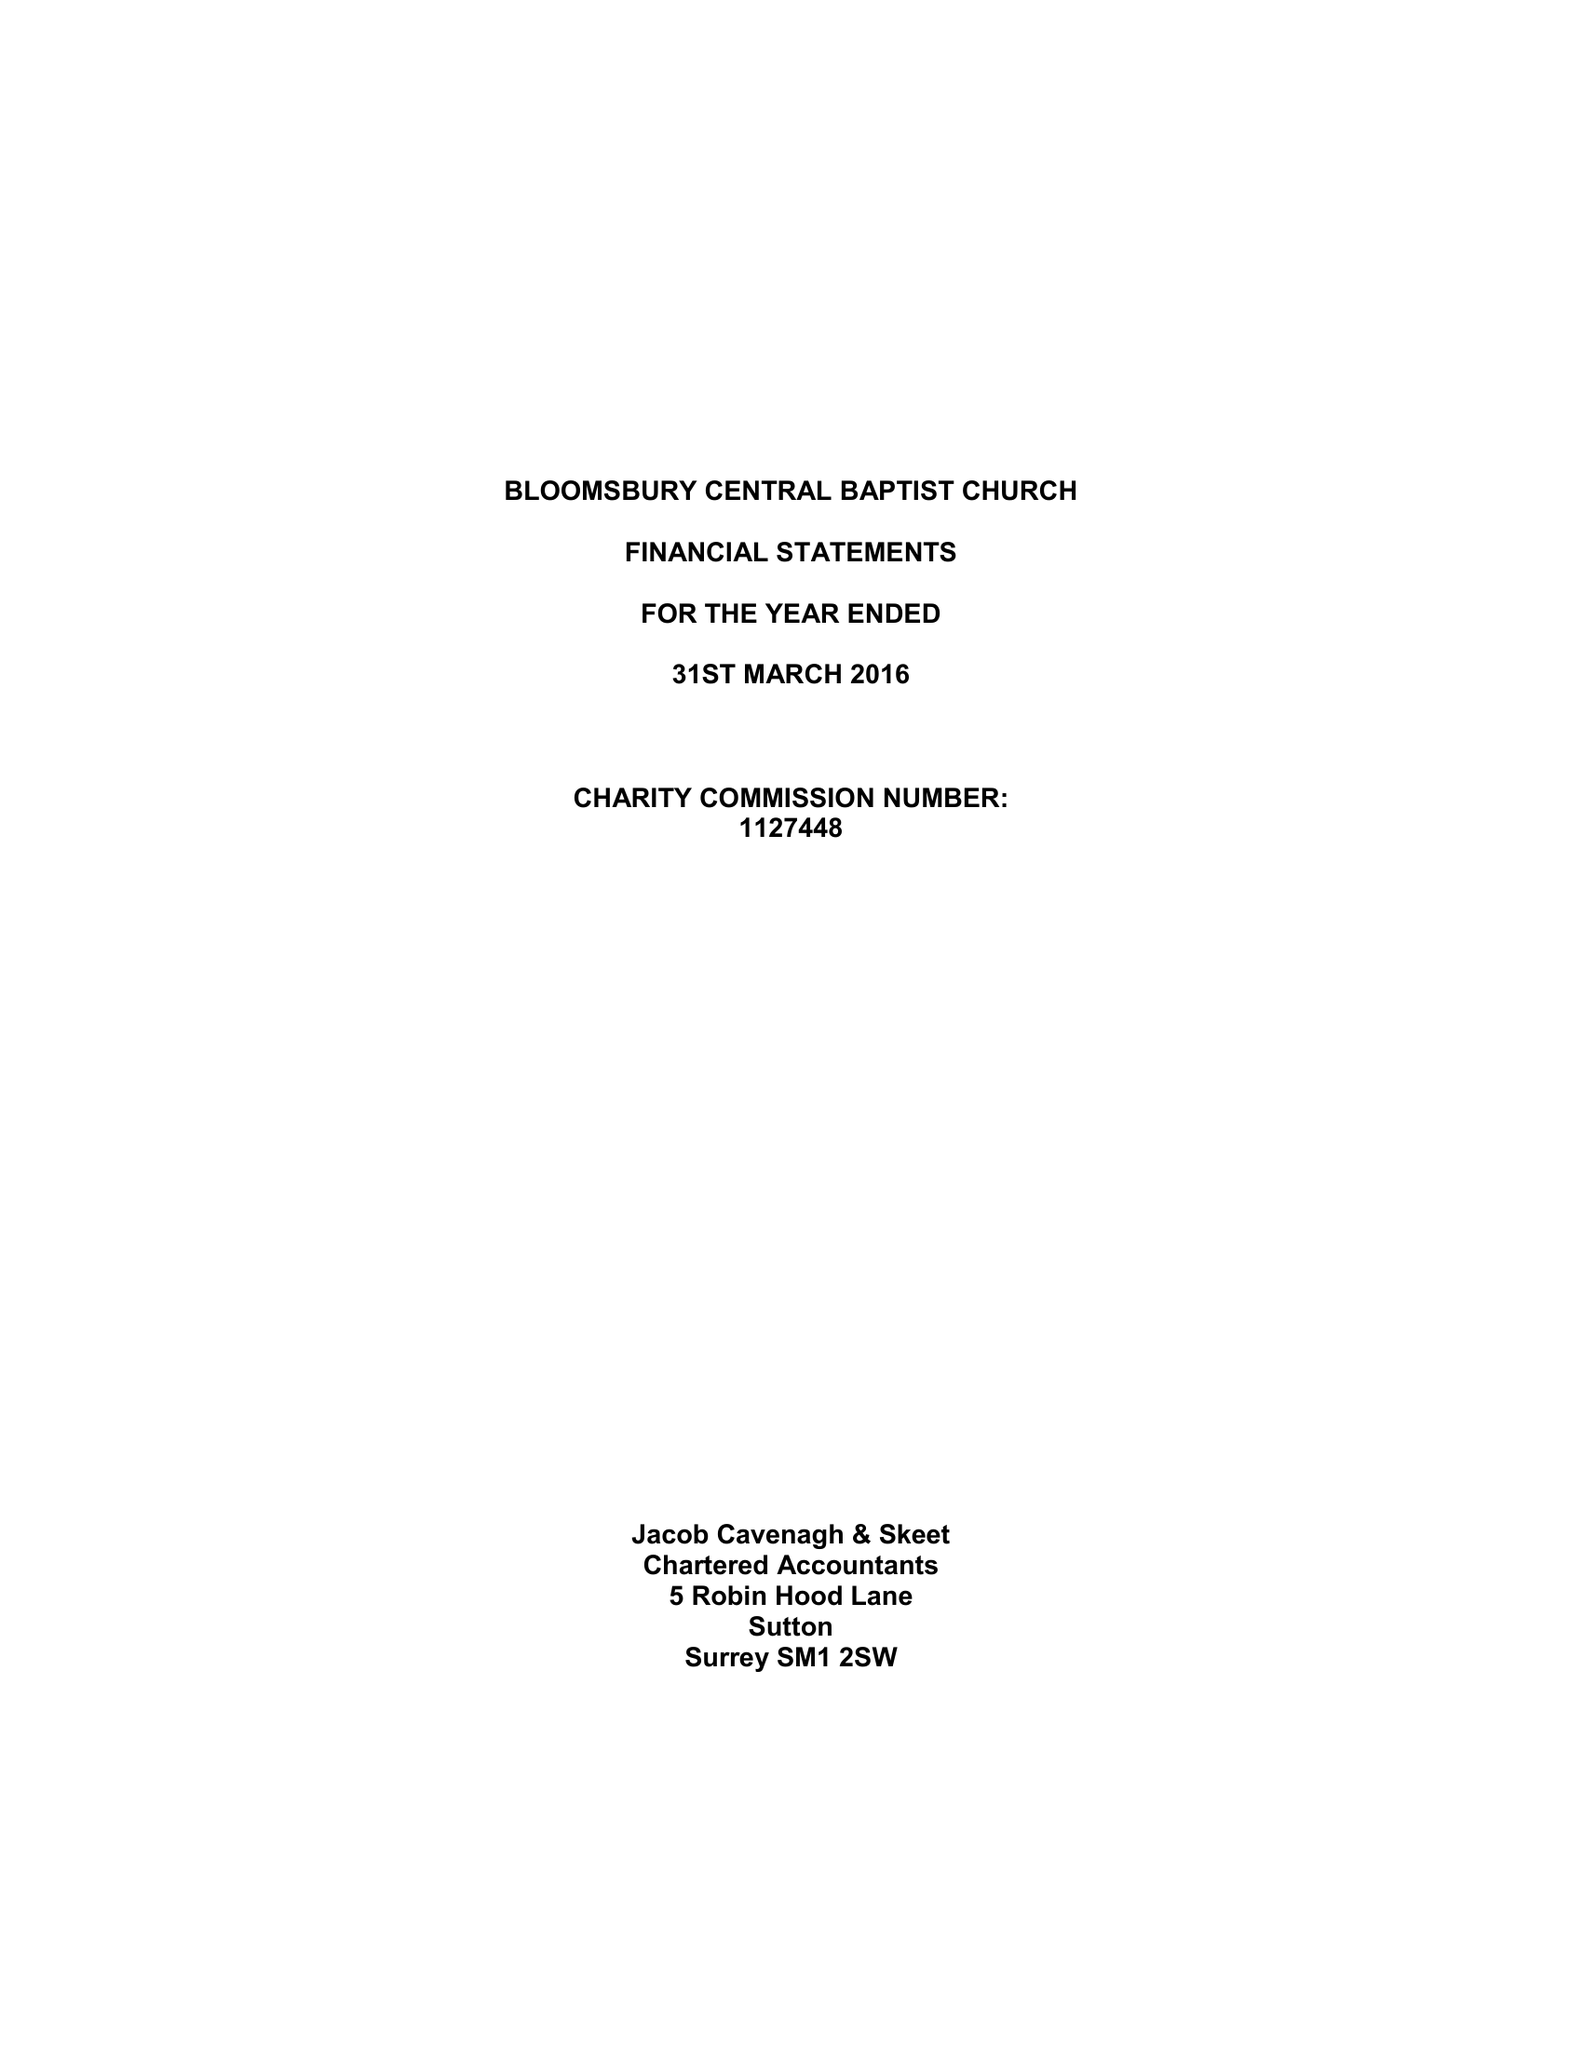What is the value for the report_date?
Answer the question using a single word or phrase. 2016-03-31 